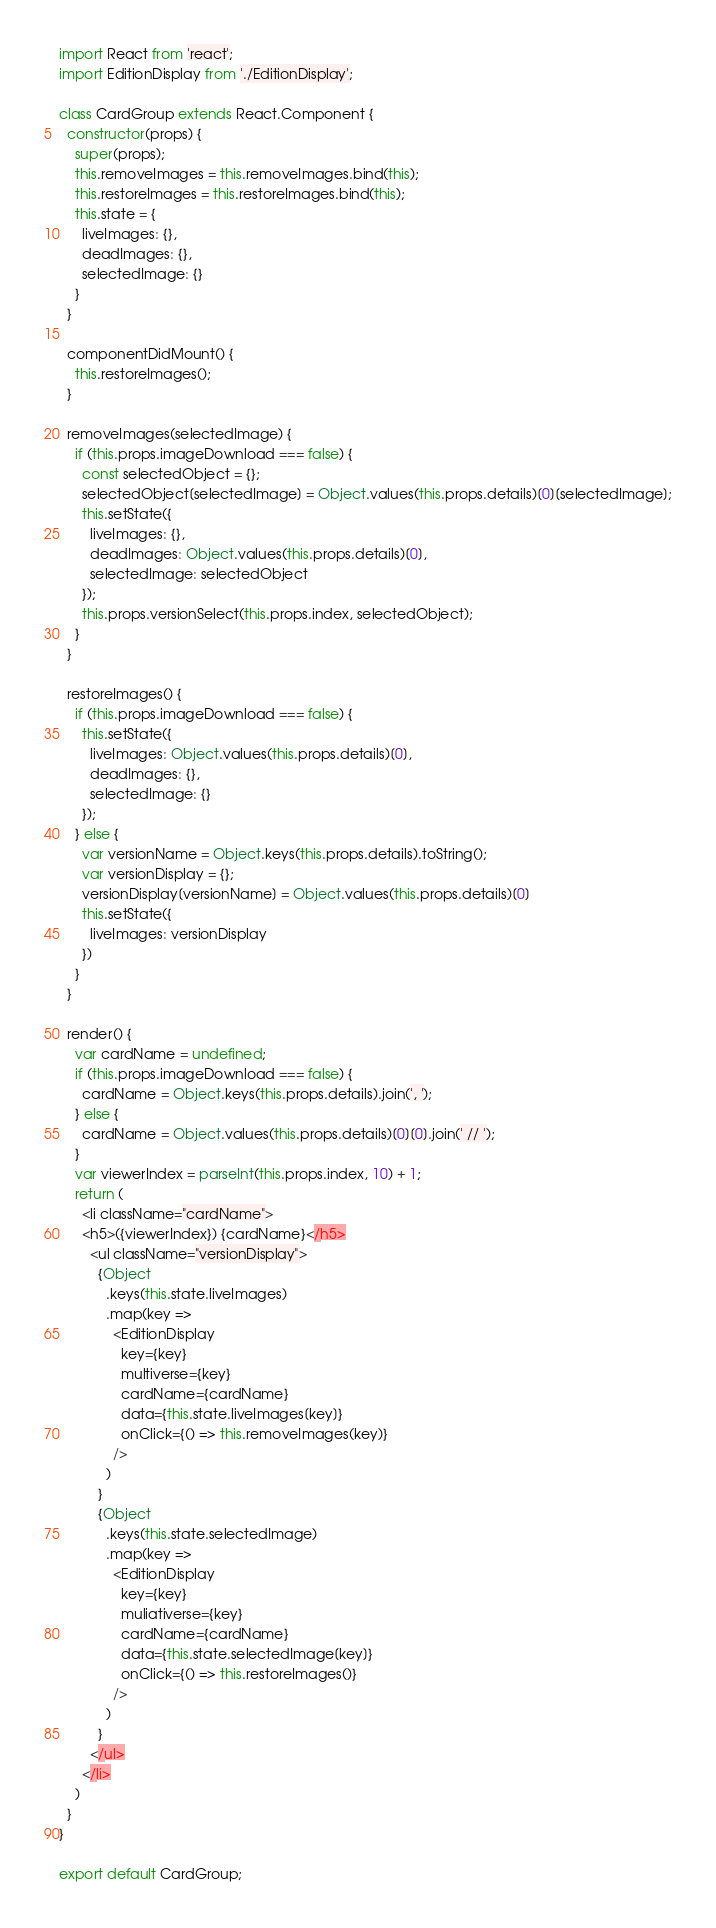Convert code to text. <code><loc_0><loc_0><loc_500><loc_500><_JavaScript_>import React from 'react';
import EditionDisplay from './EditionDisplay';

class CardGroup extends React.Component {
  constructor(props) {
    super(props);
    this.removeImages = this.removeImages.bind(this);
    this.restoreImages = this.restoreImages.bind(this);
    this.state = {
      liveImages: {},
      deadImages: {},
      selectedImage: {}
    }
  }

  componentDidMount() {
    this.restoreImages();
  }

  removeImages(selectedImage) {
    if (this.props.imageDownload === false) {
      const selectedObject = {};
      selectedObject[selectedImage] = Object.values(this.props.details)[0][selectedImage];
      this.setState({
        liveImages: {}, 
        deadImages: Object.values(this.props.details)[0],
        selectedImage: selectedObject
      });
      this.props.versionSelect(this.props.index, selectedObject);
    }
  }

  restoreImages() {
    if (this.props.imageDownload === false) {
      this.setState({
        liveImages: Object.values(this.props.details)[0],
        deadImages: {},
        selectedImage: {}
      });
    } else {
      var versionName = Object.keys(this.props.details).toString();
      var versionDisplay = {};
      versionDisplay[versionName] = Object.values(this.props.details)[0]
      this.setState({
        liveImages: versionDisplay
      })
    }
  }

  render() {
    var cardName = undefined;
    if (this.props.imageDownload === false) {
      cardName = Object.keys(this.props.details).join(', ');
    } else {
      cardName = Object.values(this.props.details)[0][0].join(' // ');
    }
    var viewerIndex = parseInt(this.props.index, 10) + 1;
    return (
      <li className="cardName">
      <h5>({viewerIndex}) {cardName}</h5>
        <ul className="versionDisplay">
          {Object
            .keys(this.state.liveImages)
            .map(key => 
              <EditionDisplay 
                key={key} 
                multiverse={key} 
                cardName={cardName} 
                data={this.state.liveImages[key]} 
                onClick={() => this.removeImages(key)}
              />                  
            )
          }
          {Object
            .keys(this.state.selectedImage)
            .map(key => 
              <EditionDisplay 
                key={key} 
                muliativerse={key} 
                cardName={cardName} 
                data={this.state.selectedImage[key]}
                onClick={() => this.restoreImages()}
              /> 
            )
          }
        </ul>
      </li>
    )
  }
}

export default CardGroup;</code> 